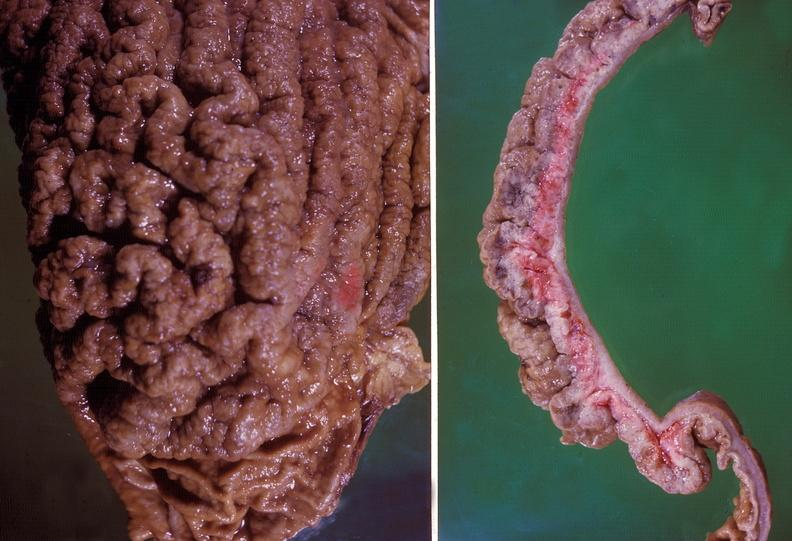s gastrointestinal present?
Answer the question using a single word or phrase. Yes 